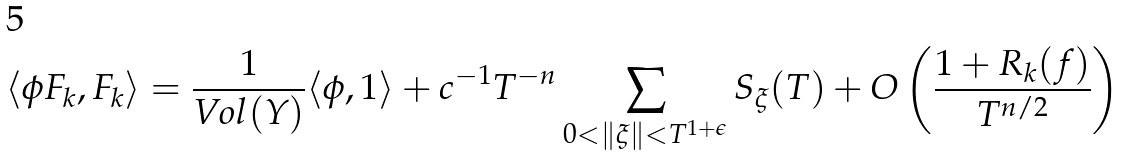Convert formula to latex. <formula><loc_0><loc_0><loc_500><loc_500>\langle \phi F _ { k } , F _ { k } \rangle = \frac { 1 } { V o l ( Y ) } \langle \phi , 1 \rangle + c ^ { - 1 } T ^ { - n } \sum _ { 0 < \| \xi \| < T ^ { 1 + \epsilon } } S _ { \xi } ( T ) + O \left ( \frac { 1 + R _ { k } ( f ) } { T ^ { n / 2 } } \right )</formula> 